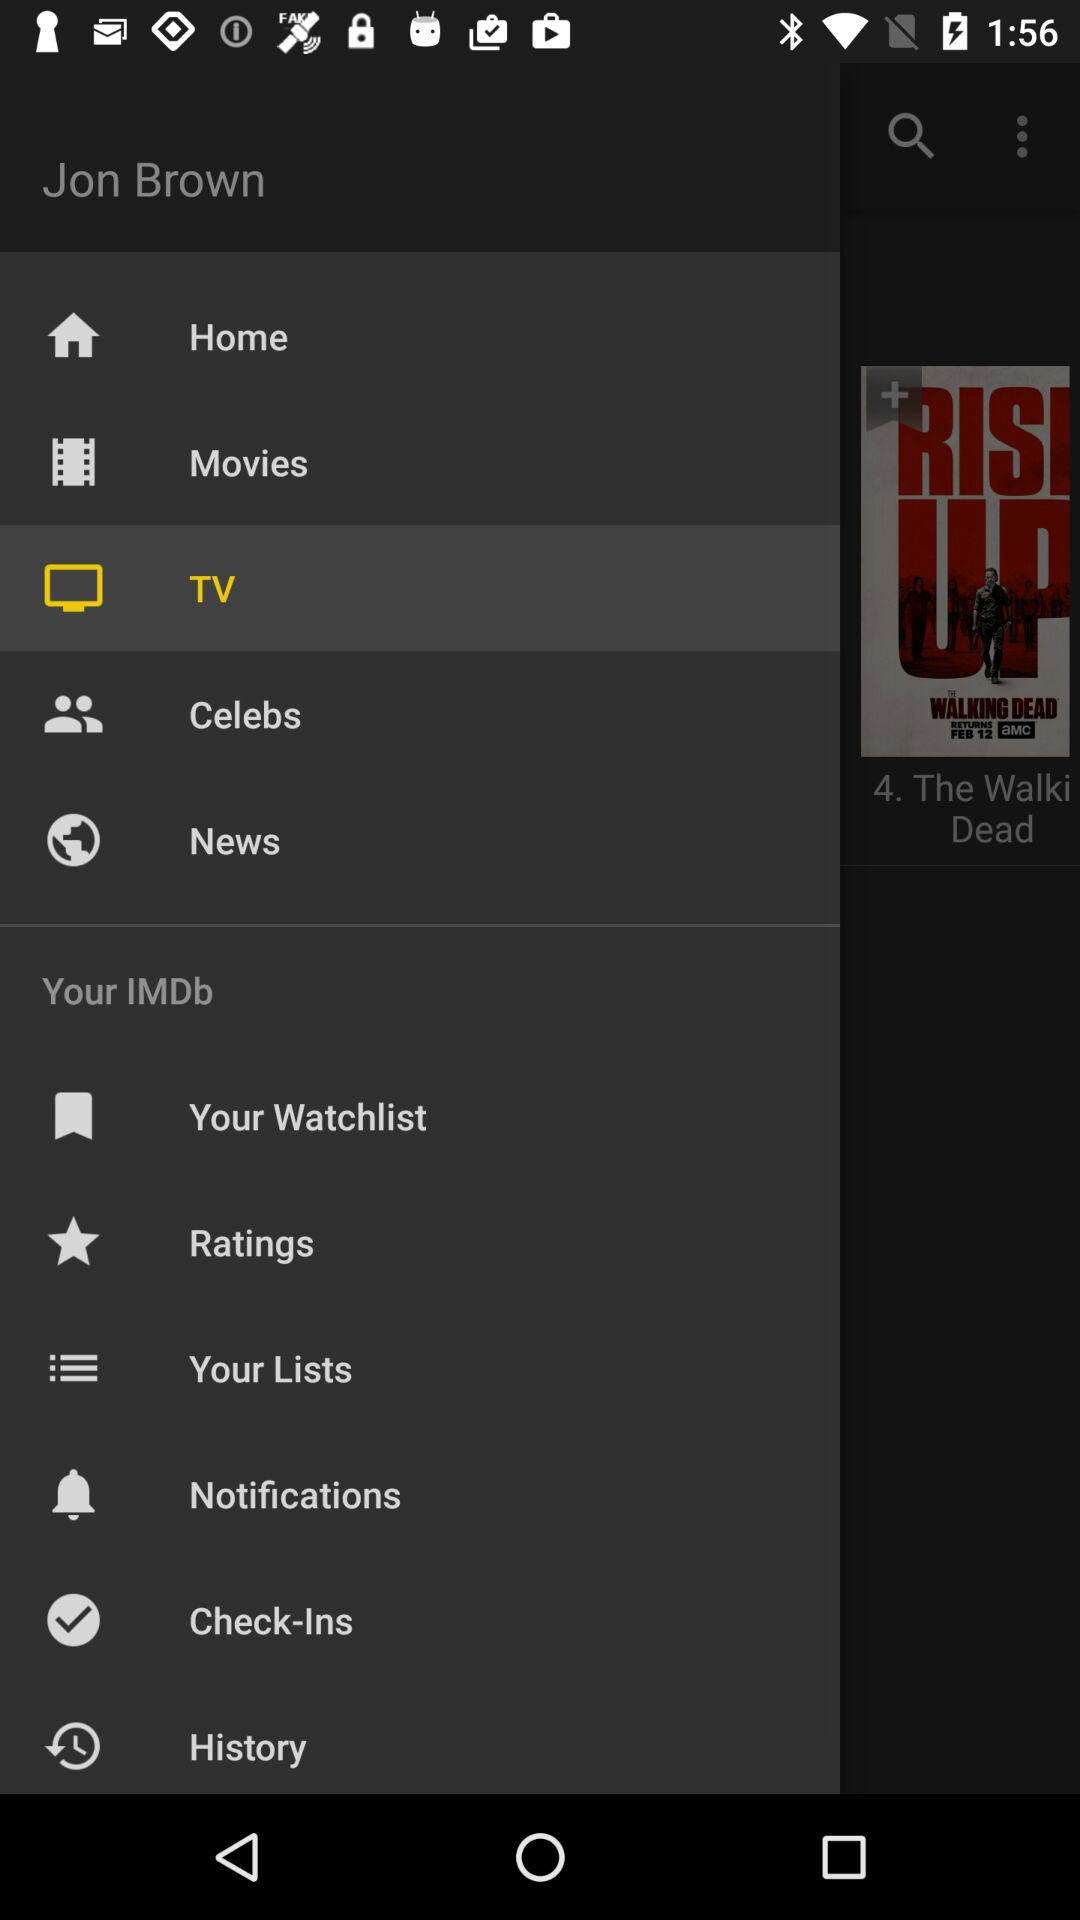What is the name of the user? The name of the user is Jon Brown. 